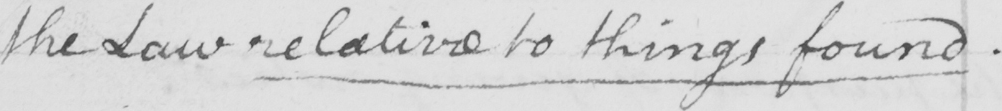Please provide the text content of this handwritten line. the Law relative to things found . 